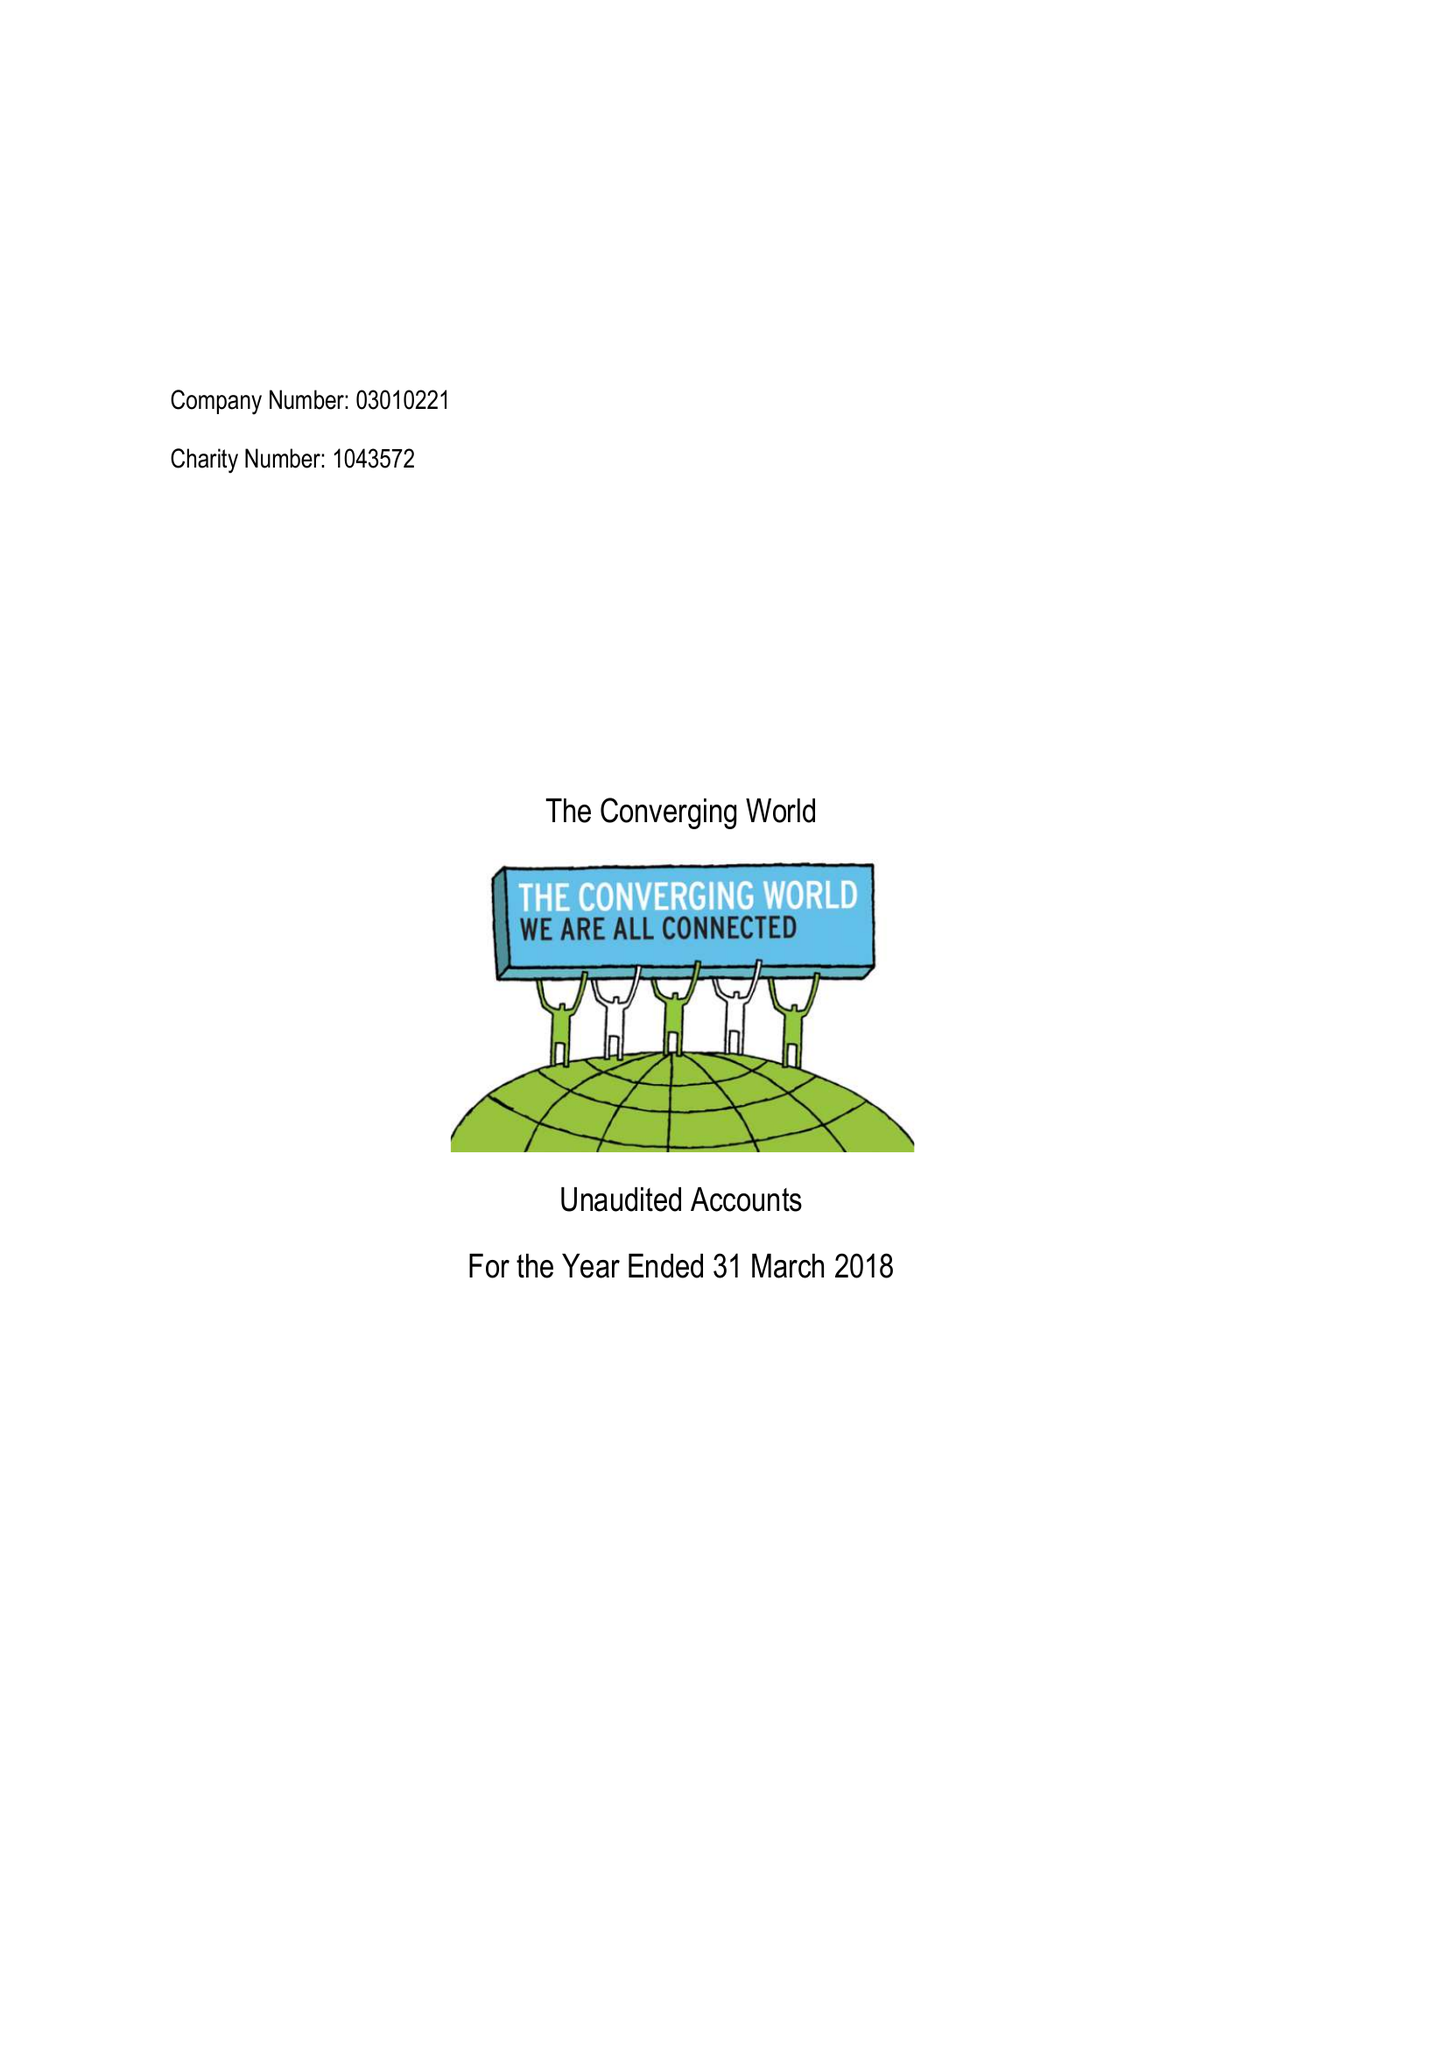What is the value for the charity_name?
Answer the question using a single word or phrase. The Converging World 